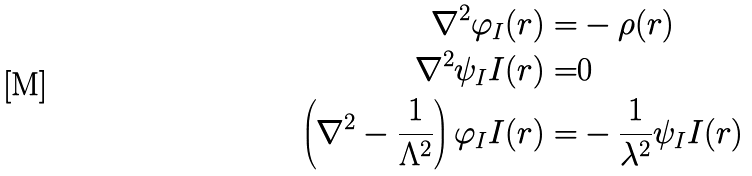<formula> <loc_0><loc_0><loc_500><loc_500>\nabla ^ { 2 } \varphi _ { I } ( r ) = & - \rho ( r ) \\ \nabla ^ { 2 } \psi _ { I } I ( r ) = & 0 \\ \left ( \nabla ^ { 2 } - \frac { 1 } { \Lambda ^ { 2 } } \right ) \varphi _ { I } I ( r ) = & - \frac { 1 } { \lambda ^ { 2 } } \psi _ { I } I ( r )</formula> 